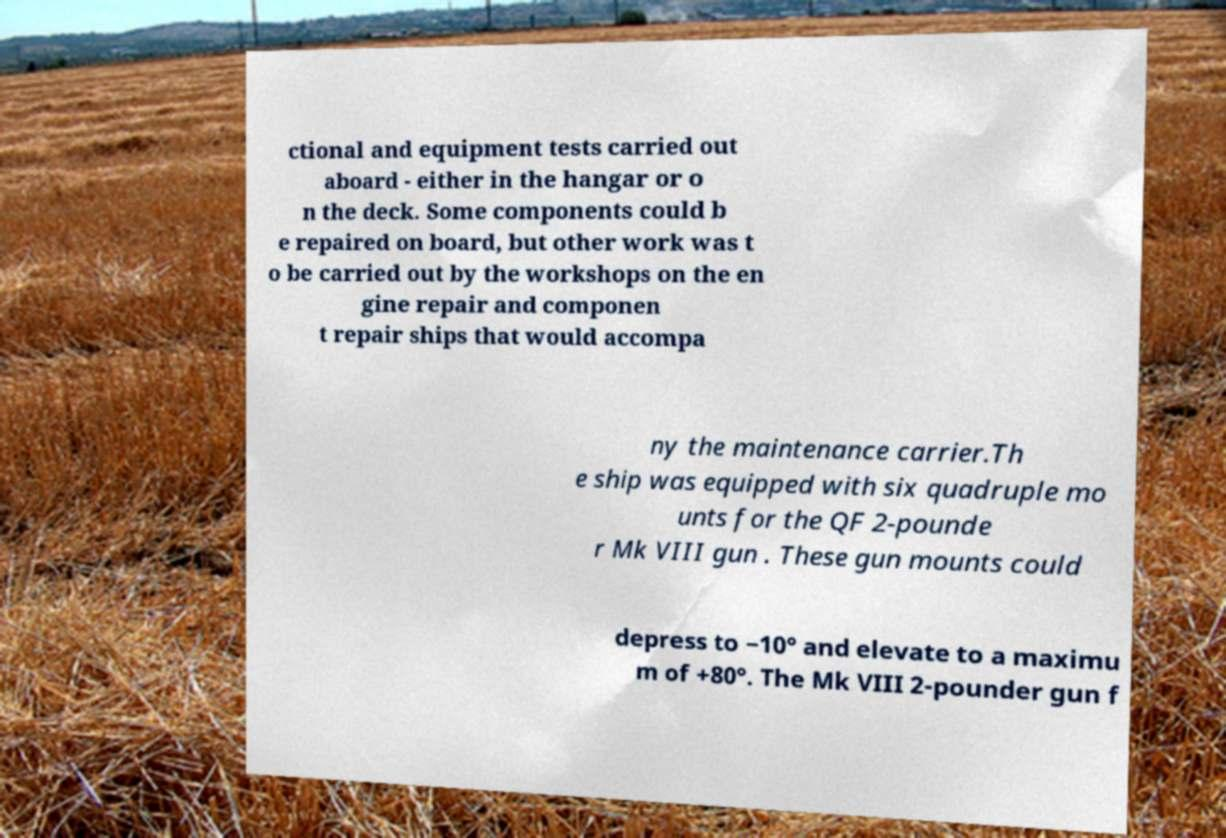What messages or text are displayed in this image? I need them in a readable, typed format. ctional and equipment tests carried out aboard - either in the hangar or o n the deck. Some components could b e repaired on board, but other work was t o be carried out by the workshops on the en gine repair and componen t repair ships that would accompa ny the maintenance carrier.Th e ship was equipped with six quadruple mo unts for the QF 2-pounde r Mk VIII gun . These gun mounts could depress to −10° and elevate to a maximu m of +80°. The Mk VIII 2-pounder gun f 